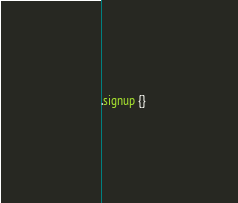Convert code to text. <code><loc_0><loc_0><loc_500><loc_500><_CSS_>.signup {}
</code> 